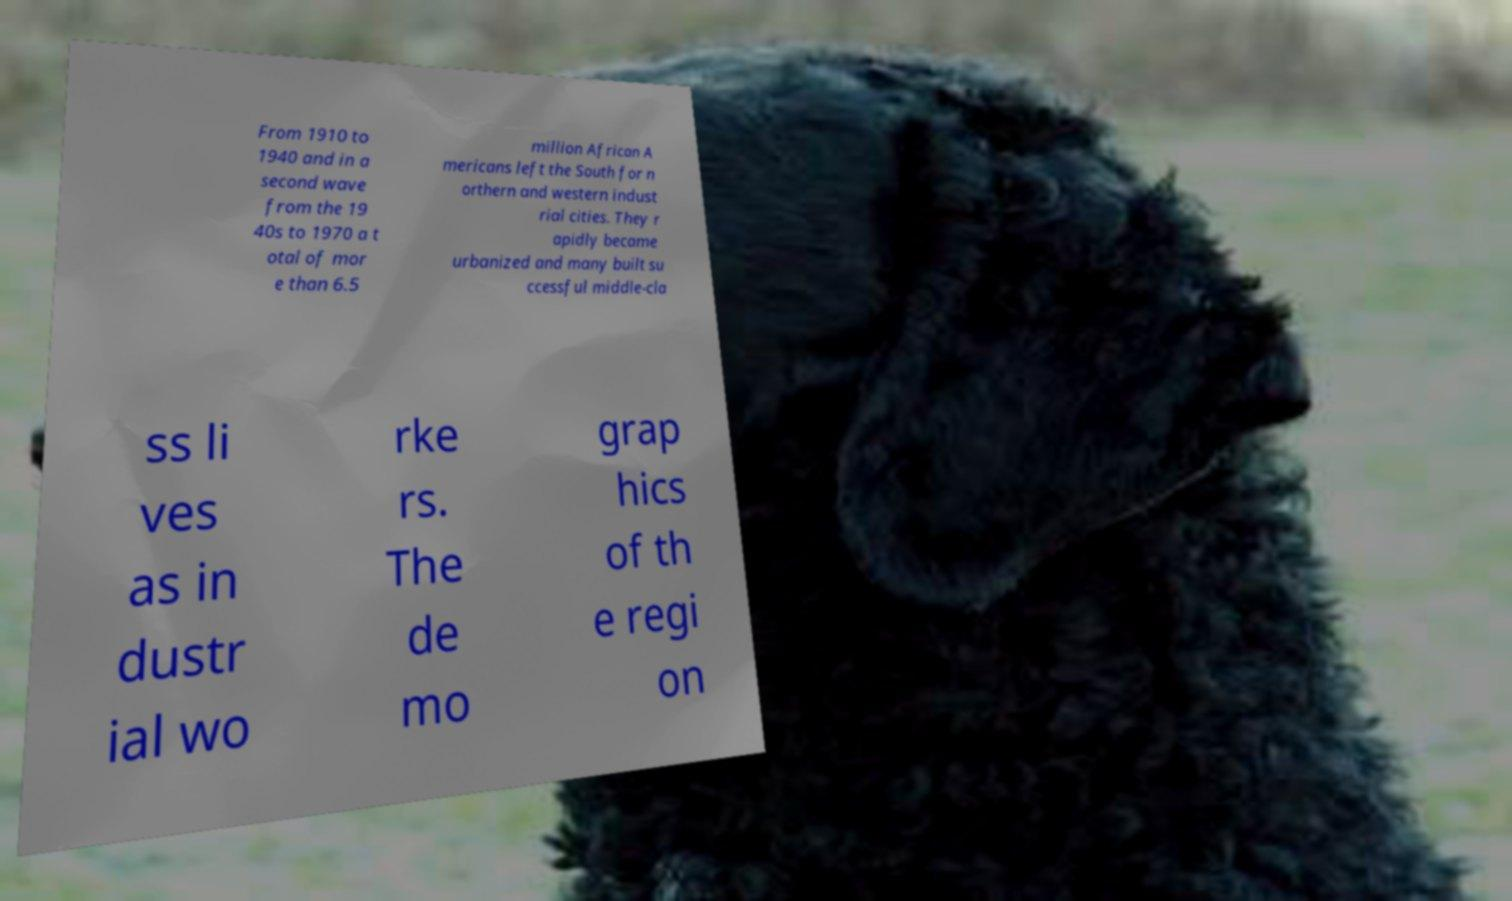Could you extract and type out the text from this image? From 1910 to 1940 and in a second wave from the 19 40s to 1970 a t otal of mor e than 6.5 million African A mericans left the South for n orthern and western indust rial cities. They r apidly became urbanized and many built su ccessful middle-cla ss li ves as in dustr ial wo rke rs. The de mo grap hics of th e regi on 